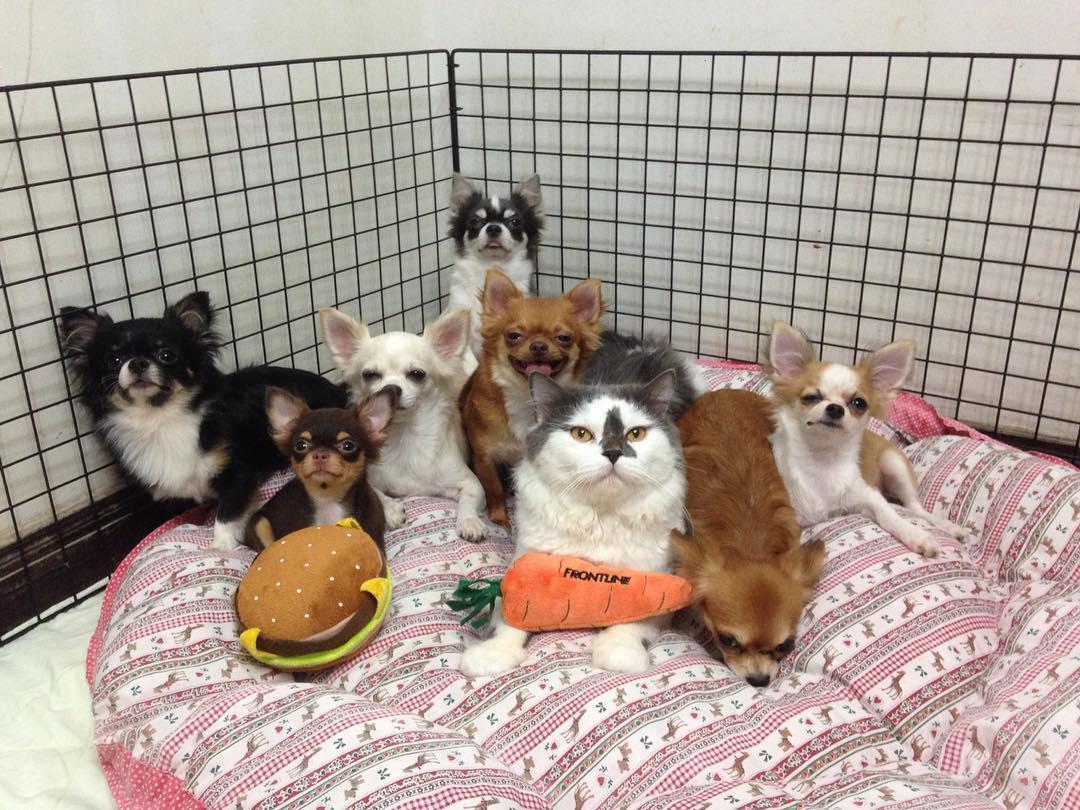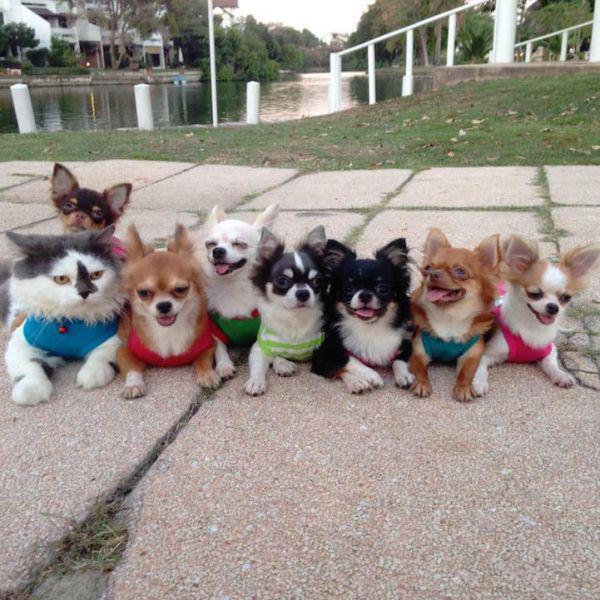The first image is the image on the left, the second image is the image on the right. For the images shown, is this caption "There s exactly one cat that is not wearing any clothing." true? Answer yes or no. Yes. 